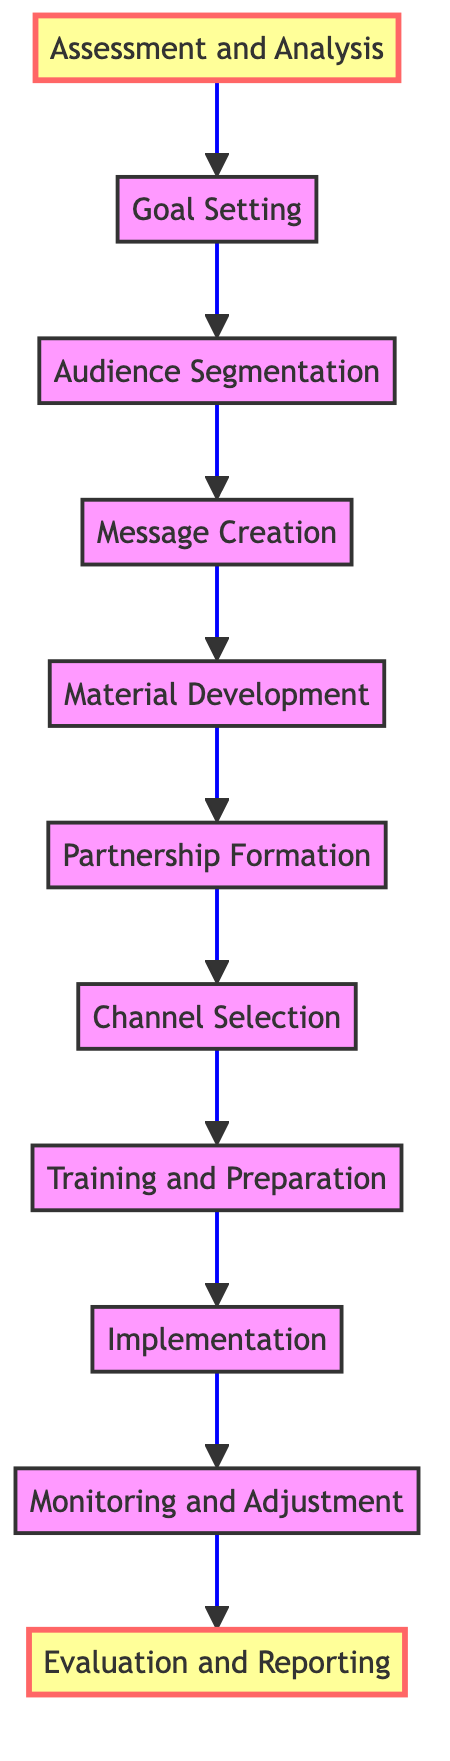What is the first step in the campaign development? The diagram indicates that the first step is "Assessment and Analysis." This is the starting point of the flow, which is positioned at the bottom of the diagram.
Answer: Assessment and Analysis How many nodes are in the flow chart? By counting each individual step provided in the diagram, there are a total of eleven nodes. Each step represents a distinct phase in the campaign development process.
Answer: Eleven Which element follows "Material Development"? In the flow, "Partnership Formation" directly follows "Material Development," indicating that once materials are created, partnerships are formed next in the process.
Answer: Partnership Formation What is the last step of the campaign development process? The final step, as indicated at the top of the flow chart, is "Evaluation and Reporting," which signifies that this is where the assessment of the campaign's impact takes place.
Answer: Evaluation and Reporting What steps are involved after "Training and Preparation"? After "Training and Preparation," the next steps in the flow are "Implementation," followed by "Monitoring and Adjustment," then finally leading to "Evaluation and Reporting." This means that training is directly connected to the launch and subsequent oversight of the campaign.
Answer: Implementation, Monitoring and Adjustment, Evaluation and Reporting What is the relationship between "Audience Segmentation" and "Message Creation"? "Audience Segmentation" directly leads to "Message Creation," meaning that the identification of target demographics is a prerequisite for developing tailored fire prevention messages.
Answer: Audience Segmentation leads to Message Creation What is the purpose of the "Channel Selection" step? The "Channel Selection" step aims to identify the appropriate platforms for disseminating the fire prevention messages. This step is essential as it helps determine where the audience will be reached most effectively.
Answer: Choose appropriate platforms for dissemination What does the diagram highlight at its beginning and end? The diagram highlights "Assessment and Analysis" at the beginning and "Evaluation and Reporting" at the end. These highlighted steps indicate critical phases in the campaign's lifecycle, emphasizing the importance of both assessing needs and evaluating outcomes.
Answer: Assessment and Analysis, Evaluation and Reporting 